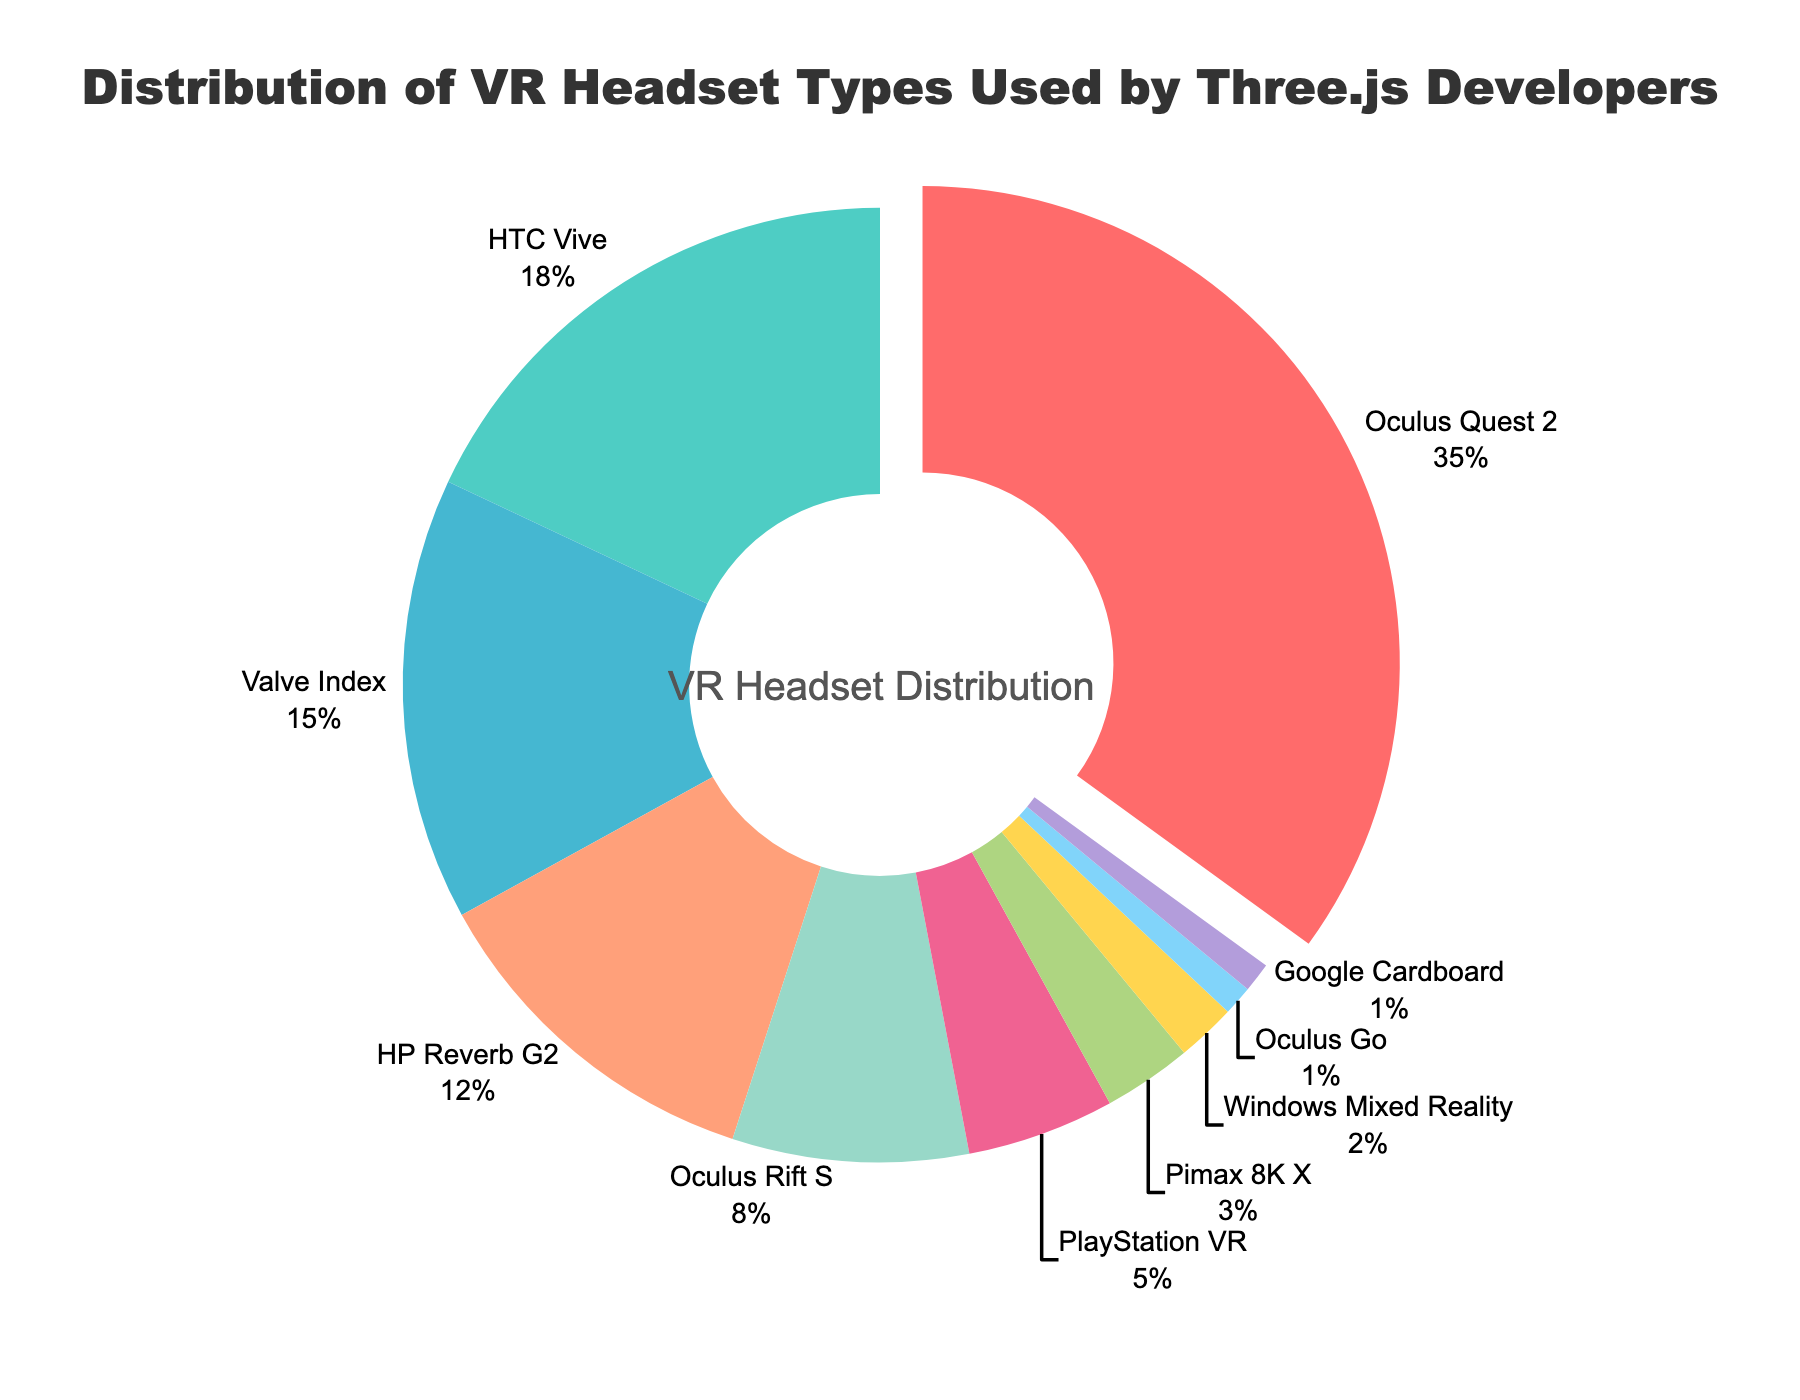What percentage of Three.js developers use Valve Index? The figure shows the percentage distribution for each VR headset, and we can see that Valve Index is 15%.
Answer: 15% Which VR headset is the most popular among Three.js developers? The largest slice in the donut chart corresponds to Oculus Quest 2, indicating it is the most popular.
Answer: Oculus Quest 2 How much more popular is Oculus Quest 2 compared to HTC Vive? Oculus Quest 2 has 35% while HTC Vive has 18%. The difference is 35% - 18%.
Answer: 17% What is the combined percentage of users for Oculus Rift S and HP Reverb G2? Oculus Rift S has 8% and HP Reverb G2 has 12%. Adding them together gives 8% + 12%.
Answer: 20% How many headsets have a usage percentage of less than 5%? PlayStation VR has 5%, and below that are Pimax 8K X (3%), Windows Mixed Reality (2%), Oculus Go (1%), and Google Cardboard (1%). This makes a total of 4 headsets.
Answer: 4 If you were to sum up the percentages of all Oculus variants, what would it be? Oculus Quest 2 (35%), Oculus Rift S (8%), Oculus Go (1%). Summing them gives 35% + 8% + 1%.
Answer: 44% Which headset has the smallest user base among Three.js developers? The smallest slices in the chart are 1%, corresponding to Oculus Go and Google Cardboard.
Answer: Oculus Go and Google Cardboard What is the difference in percentage between the least popular and the most popular headset? The most popular is Oculus Quest 2 at 35% and the least popular are Oculus Go and Google Cardboard both at 1%. The difference is 35% - 1%.
Answer: 34% Is there more than 50% of the user base using Oculus products (combined)? Adding the percentages of Oculus Quest 2 (35%), Oculus Rift S (8%), and Oculus Go (1%) gives a total of 44%. Since 44% is less than 50%, the answer is no.
Answer: No Between HP Reverb G2 and PlayStation VR, which headset is more popular and by how much? HP Reverb G2 has 12% while PlayStation VR has 5%. The difference is 12% - 5%.
Answer: HP Reverb G2 by 7% 